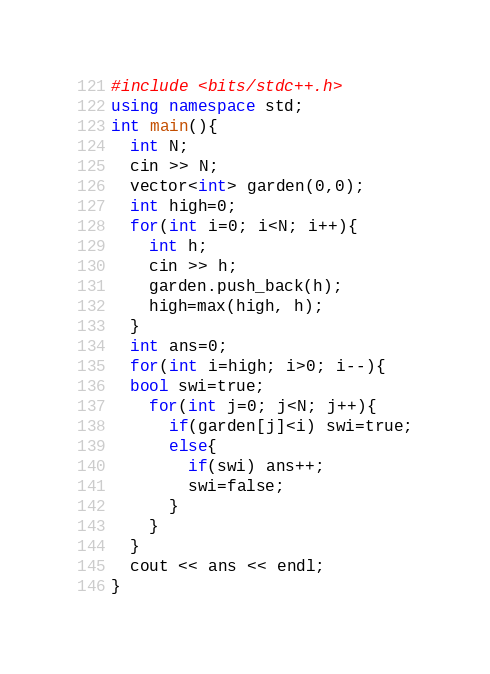Convert code to text. <code><loc_0><loc_0><loc_500><loc_500><_C++_>#include <bits/stdc++.h>
using namespace std;
int main(){
  int N;
  cin >> N;
  vector<int> garden(0,0);
  int high=0;
  for(int i=0; i<N; i++){
    int h;
    cin >> h;
    garden.push_back(h);
    high=max(high, h);
  }
  int ans=0;
  for(int i=high; i>0; i--){
  bool swi=true;  
    for(int j=0; j<N; j++){
      if(garden[j]<i) swi=true;
      else{
        if(swi) ans++;
        swi=false;
      }
    }
  }
  cout << ans << endl;
}</code> 